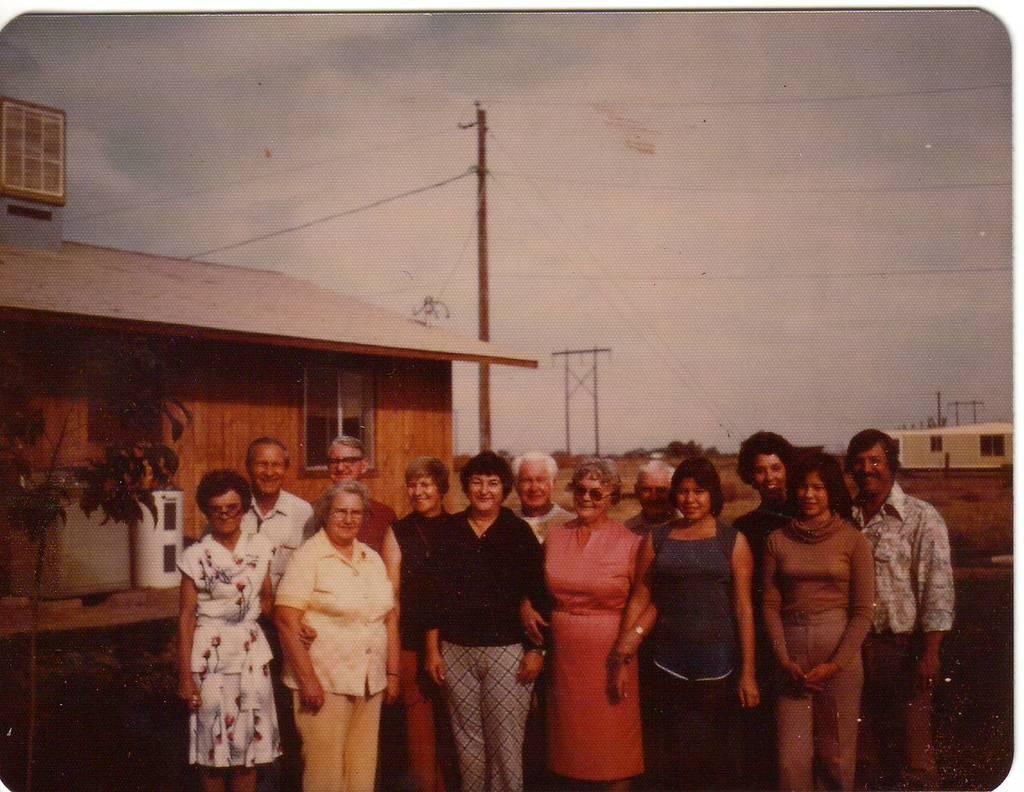What is the main subject of the image? The main subject of the image is a group of people. What are the people in the image doing? The people are standing together and smiling. What can be seen on the left side of the image? There is a wooden house on the left side of the image. What is located in the middle of the image? There is a pole in the middle of the image. What is visible at the top of the image? The sky is visible at the top of the image. How many geese are sleeping on the bed in the image? There are no geese or beds present in the image. What type of parent is shown interacting with the people in the image? There is no parent present in the image; it features a group of people standing together and smiling. 